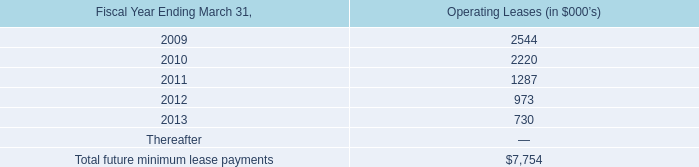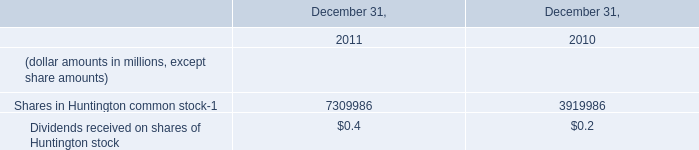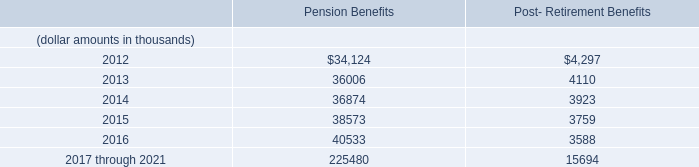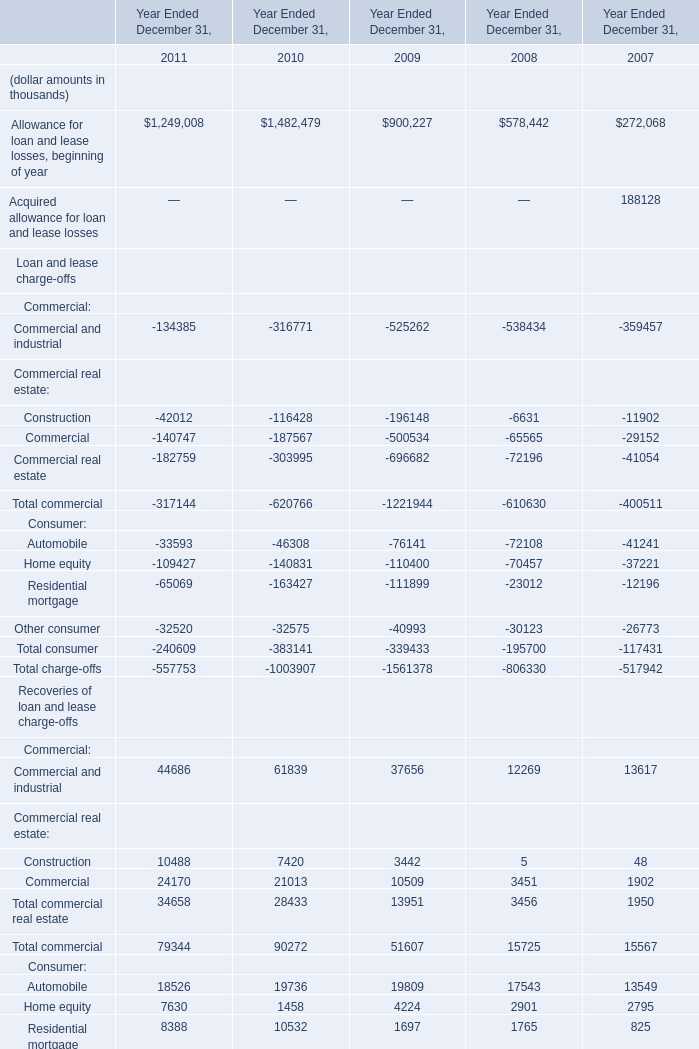What is the increasing rate of Total recoveries between 2009 and 2010? 
Computations: ((129433 - 84791) / 84791)
Answer: 0.52649. 